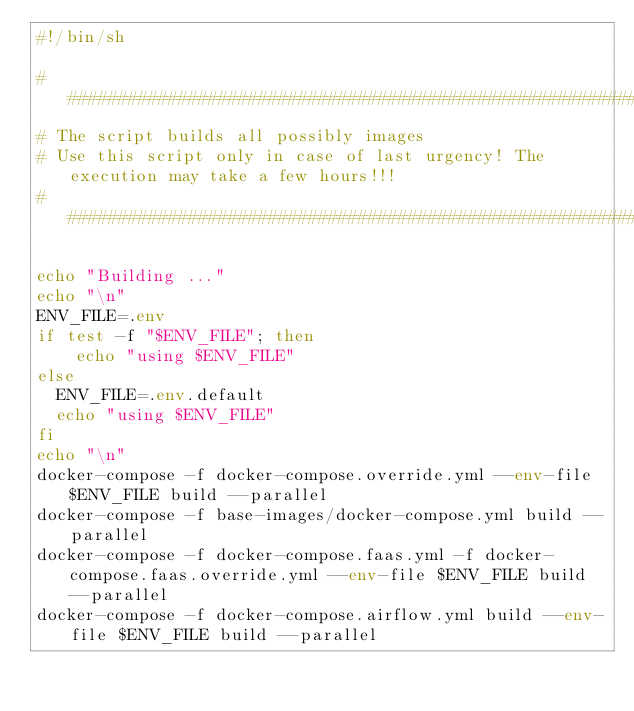<code> <loc_0><loc_0><loc_500><loc_500><_Bash_>#!/bin/sh

# ####################################################################################################################
# The script builds all possibly images
# Use this script only in case of last urgency! The execution may take a few hours!!!
# ####################################################################################################################

echo "Building ..."
echo "\n"
ENV_FILE=.env
if test -f "$ENV_FILE"; then
    echo "using $ENV_FILE"
else
  ENV_FILE=.env.default
  echo "using $ENV_FILE"
fi
echo "\n"
docker-compose -f docker-compose.override.yml --env-file $ENV_FILE build --parallel
docker-compose -f base-images/docker-compose.yml build --parallel
docker-compose -f docker-compose.faas.yml -f docker-compose.faas.override.yml --env-file $ENV_FILE build --parallel
docker-compose -f docker-compose.airflow.yml build --env-file $ENV_FILE build --parallel
</code> 